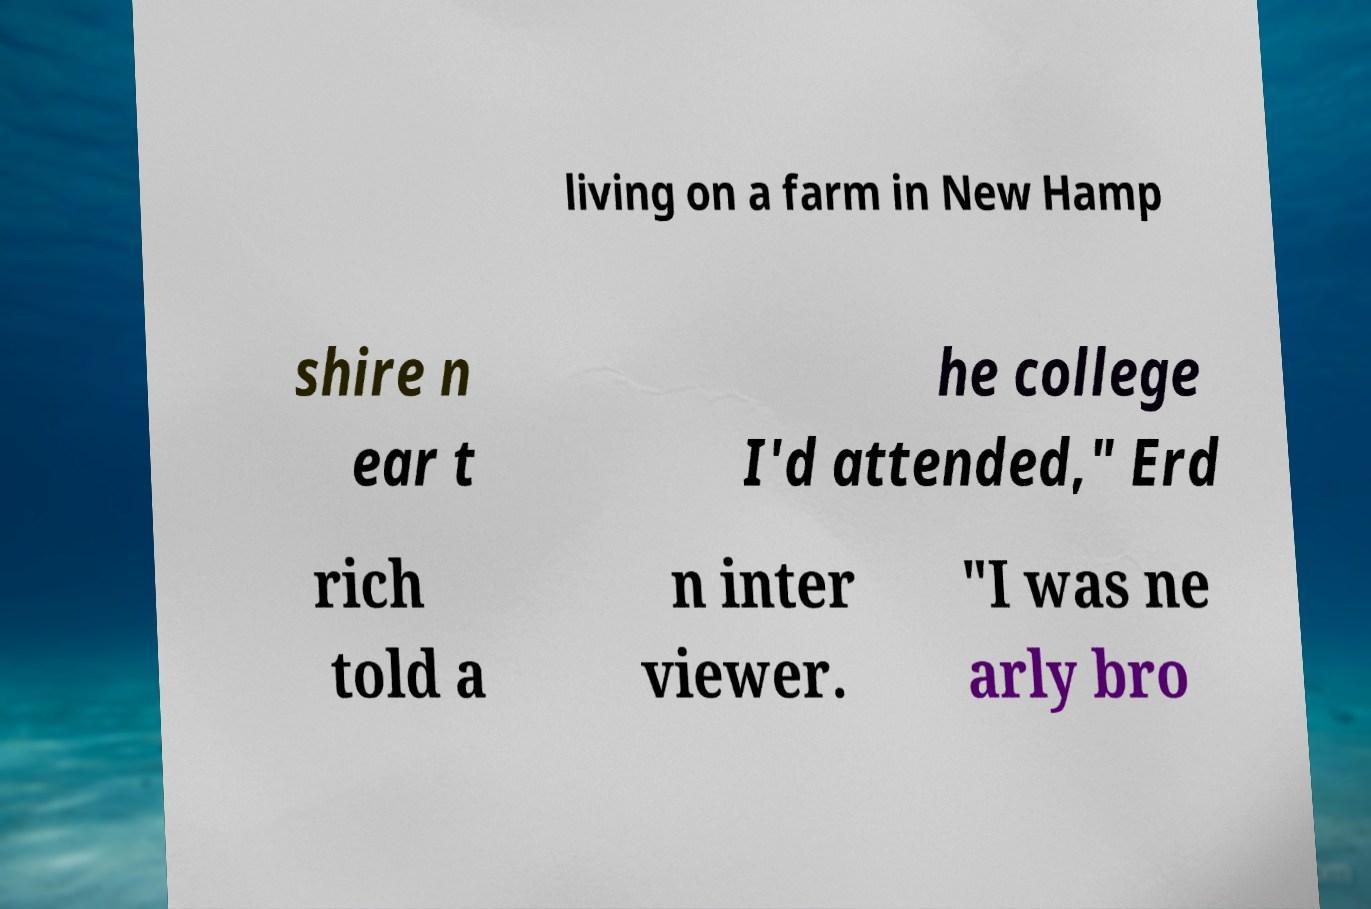Could you extract and type out the text from this image? living on a farm in New Hamp shire n ear t he college I'd attended," Erd rich told a n inter viewer. "I was ne arly bro 